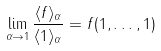<formula> <loc_0><loc_0><loc_500><loc_500>\lim _ { \alpha \to 1 } \frac { \langle f \rangle _ { \alpha } } { \langle 1 \rangle _ { \alpha } } = f ( 1 , \dots , 1 )</formula> 